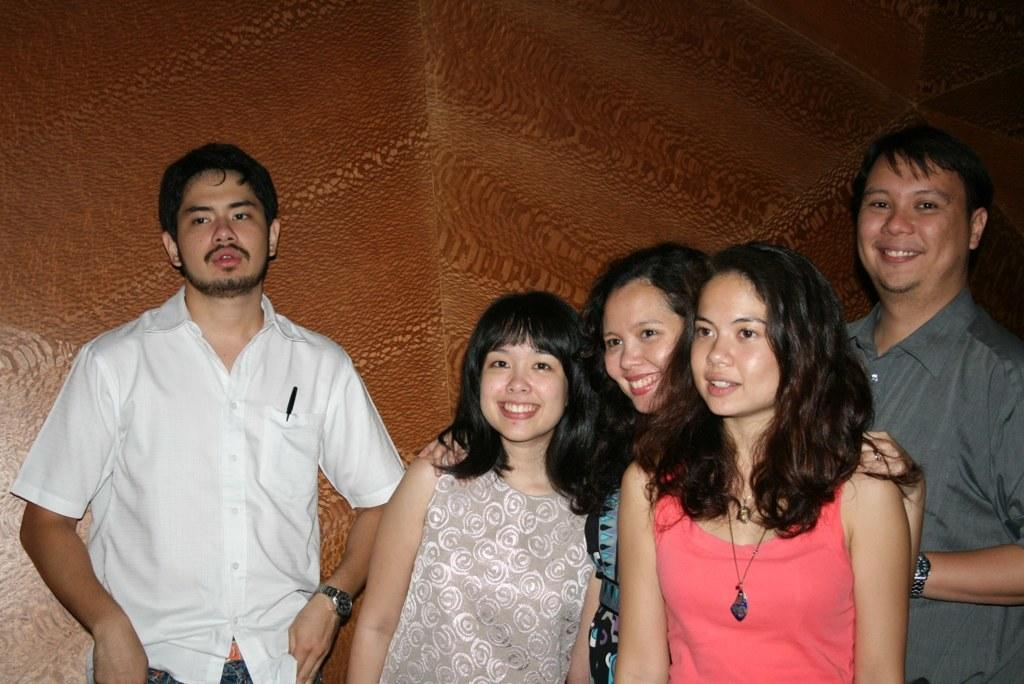What is happening in the image involving a group of people? There is a group of people in the image, and they are standing and watching. Can you describe the expressions on the faces of some people in the image? Some people in the image are smiling. What can be seen in the background of the image? There is a wall in the background of the image. What type of grass is growing on the wall in the image? There is no grass visible in the image, and the wall is in the background. 